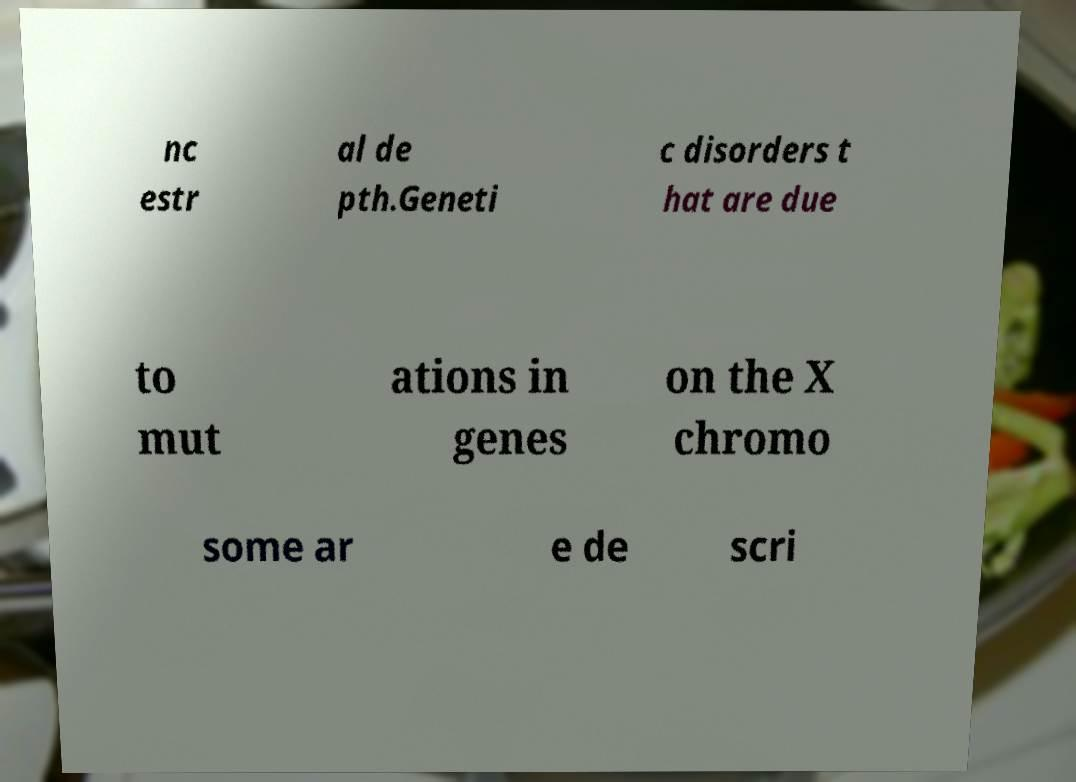For documentation purposes, I need the text within this image transcribed. Could you provide that? nc estr al de pth.Geneti c disorders t hat are due to mut ations in genes on the X chromo some ar e de scri 